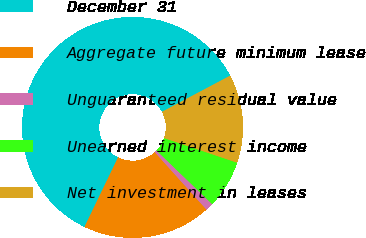<chart> <loc_0><loc_0><loc_500><loc_500><pie_chart><fcel>December 31<fcel>Aggregate future minimum lease<fcel>Unguaranteed residual value<fcel>Unearned interest income<fcel>Net investment in leases<nl><fcel>60.08%<fcel>18.82%<fcel>1.14%<fcel>7.03%<fcel>12.93%<nl></chart> 